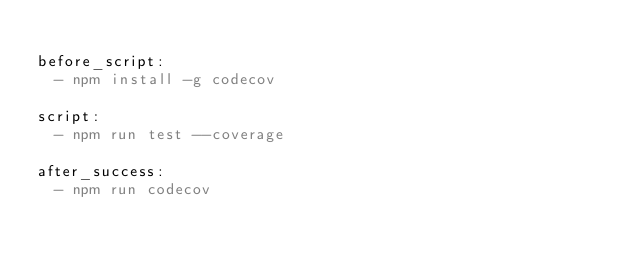Convert code to text. <code><loc_0><loc_0><loc_500><loc_500><_YAML_>
before_script:
  - npm install -g codecov

script:
  - npm run test --coverage

after_success:
  - npm run codecov
</code> 